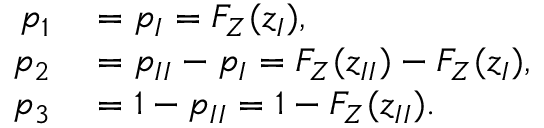Convert formula to latex. <formula><loc_0><loc_0><loc_500><loc_500>\begin{array} { r l } { p _ { 1 } } & = p _ { I } = F _ { Z } ( z _ { I } ) , } \\ { p _ { 2 } } & = p _ { I I } - p _ { I } = F _ { Z } ( z _ { I I } ) - F _ { Z } ( z _ { I } ) , } \\ { p _ { 3 } } & = 1 - p _ { I I } = 1 - F _ { Z } ( z _ { I I } ) . } \end{array}</formula> 